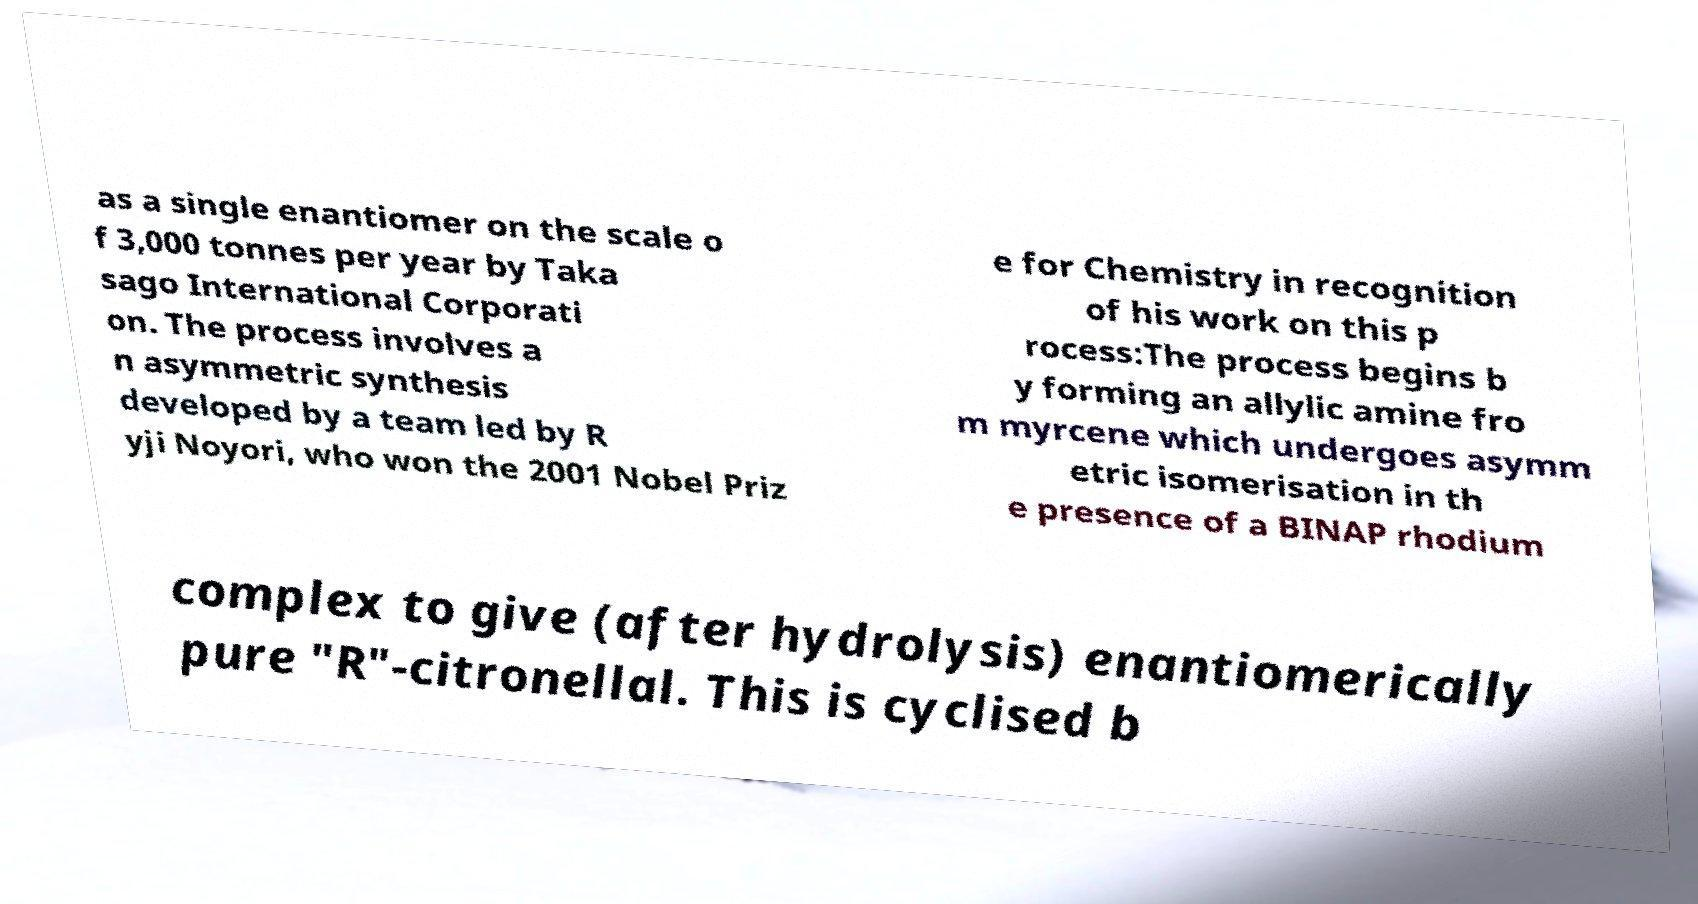Could you extract and type out the text from this image? as a single enantiomer on the scale o f 3,000 tonnes per year by Taka sago International Corporati on. The process involves a n asymmetric synthesis developed by a team led by R yji Noyori, who won the 2001 Nobel Priz e for Chemistry in recognition of his work on this p rocess:The process begins b y forming an allylic amine fro m myrcene which undergoes asymm etric isomerisation in th e presence of a BINAP rhodium complex to give (after hydrolysis) enantiomerically pure "R"-citronellal. This is cyclised b 